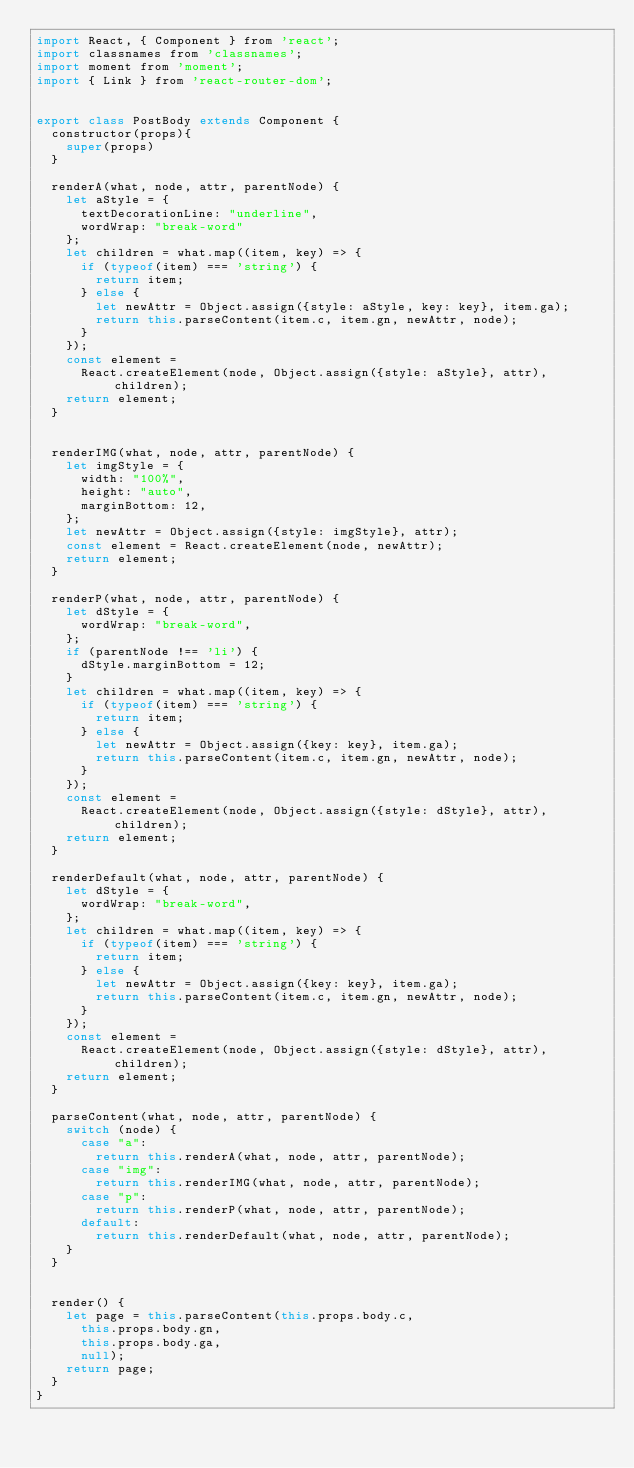Convert code to text. <code><loc_0><loc_0><loc_500><loc_500><_JavaScript_>import React, { Component } from 'react';
import classnames from 'classnames';
import moment from 'moment';
import { Link } from 'react-router-dom';


export class PostBody extends Component {
  constructor(props){
    super(props)
  }

  renderA(what, node, attr, parentNode) {
    let aStyle = {
      textDecorationLine: "underline",
      wordWrap: "break-word"
    };
    let children = what.map((item, key) => {
      if (typeof(item) === 'string') {
        return item;
      } else {
        let newAttr = Object.assign({style: aStyle, key: key}, item.ga);
        return this.parseContent(item.c, item.gn, newAttr, node);
      }
    });
    const element =
      React.createElement(node, Object.assign({style: aStyle}, attr), children);
    return element;
  }


  renderIMG(what, node, attr, parentNode) {
    let imgStyle = {
      width: "100%",
      height: "auto",
      marginBottom: 12,
    };
    let newAttr = Object.assign({style: imgStyle}, attr);
    const element = React.createElement(node, newAttr);
    return element;
  }

  renderP(what, node, attr, parentNode) {
    let dStyle = {
      wordWrap: "break-word",
    };
    if (parentNode !== 'li') {
      dStyle.marginBottom = 12;
    }
    let children = what.map((item, key) => {
      if (typeof(item) === 'string') {
        return item;
      } else {
        let newAttr = Object.assign({key: key}, item.ga);
        return this.parseContent(item.c, item.gn, newAttr, node);
      }
    });
    const element =
      React.createElement(node, Object.assign({style: dStyle}, attr), children);
    return element;
  }

  renderDefault(what, node, attr, parentNode) {
    let dStyle = {
      wordWrap: "break-word",
    };
    let children = what.map((item, key) => {
      if (typeof(item) === 'string') {
        return item;
      } else {
        let newAttr = Object.assign({key: key}, item.ga);
        return this.parseContent(item.c, item.gn, newAttr, node);
      }
    });
    const element =
      React.createElement(node, Object.assign({style: dStyle}, attr), children);
    return element;
  }

  parseContent(what, node, attr, parentNode) {
    switch (node) {
      case "a":
        return this.renderA(what, node, attr, parentNode);
      case "img":
        return this.renderIMG(what, node, attr, parentNode);
      case "p":
        return this.renderP(what, node, attr, parentNode);
      default:
        return this.renderDefault(what, node, attr, parentNode);
    }
  }


  render() {
    let page = this.parseContent(this.props.body.c,
      this.props.body.gn,
      this.props.body.ga,
      null); 
    return page;
  }
}

</code> 